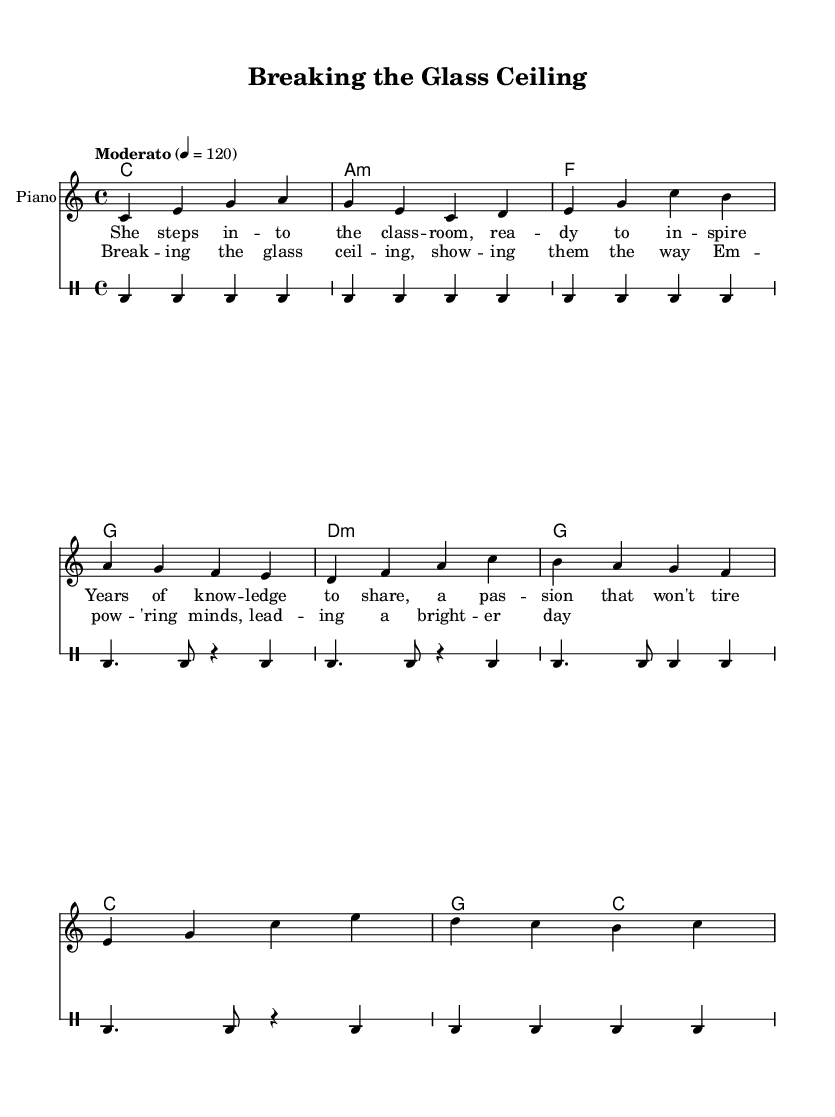What is the time signature of this music? The time signature is indicated at the beginning of the score and is shown as 4/4, meaning there are four beats in every measure and a quarter note receives one beat.
Answer: 4/4 What is the key signature of this music? The key signature is found at the start of the piece, and it is C major, which has no sharps or flats.
Answer: C major What is the tempo marking for this piece? The tempo is marked as "Moderato" with a metronome marking of 120 beats per minute, indicating a moderate pace.
Answer: Moderato How many measures are in the verse rhythm? By counting the number of distinct lines in the verse rhythm section, we find there are four measures in total, each containing a distinct rhythmic pattern.
Answer: 4 Which section contains a lyrical line about empowerment? The chorus section specifically states "Em -- pow -- 'ring minds, lead -- ing a bright -- er day," which focuses on empowerment and leadership.
Answer: Chorus What type of harmonies are used in this piece? The harmonies are primarily built on triads in a standard pop progression, including major and minor chord types such as C major, A minor, F major, and G major, following typical pop music patterns.
Answer: Major and minor chords What is the primary theme of this song? The primary theme revolves around breaking barriers and empowering women in education and leadership, as expressed through the lyrics and the title of the piece.
Answer: Empowerment 